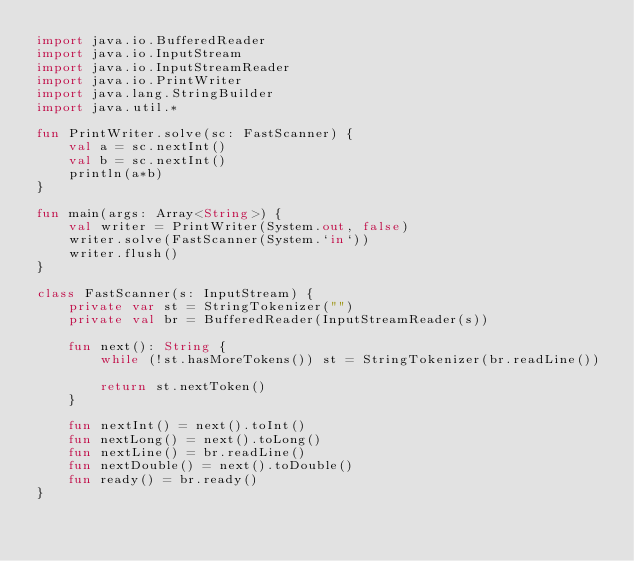Convert code to text. <code><loc_0><loc_0><loc_500><loc_500><_Kotlin_>import java.io.BufferedReader
import java.io.InputStream
import java.io.InputStreamReader
import java.io.PrintWriter
import java.lang.StringBuilder
import java.util.*

fun PrintWriter.solve(sc: FastScanner) {
    val a = sc.nextInt()
    val b = sc.nextInt()
    println(a*b)
}

fun main(args: Array<String>) {
    val writer = PrintWriter(System.out, false)
    writer.solve(FastScanner(System.`in`))
    writer.flush()
}

class FastScanner(s: InputStream) {
    private var st = StringTokenizer("")
    private val br = BufferedReader(InputStreamReader(s))

    fun next(): String {
        while (!st.hasMoreTokens()) st = StringTokenizer(br.readLine())

        return st.nextToken()
    }

    fun nextInt() = next().toInt()
    fun nextLong() = next().toLong()
    fun nextLine() = br.readLine()
    fun nextDouble() = next().toDouble()
    fun ready() = br.ready()
}
</code> 